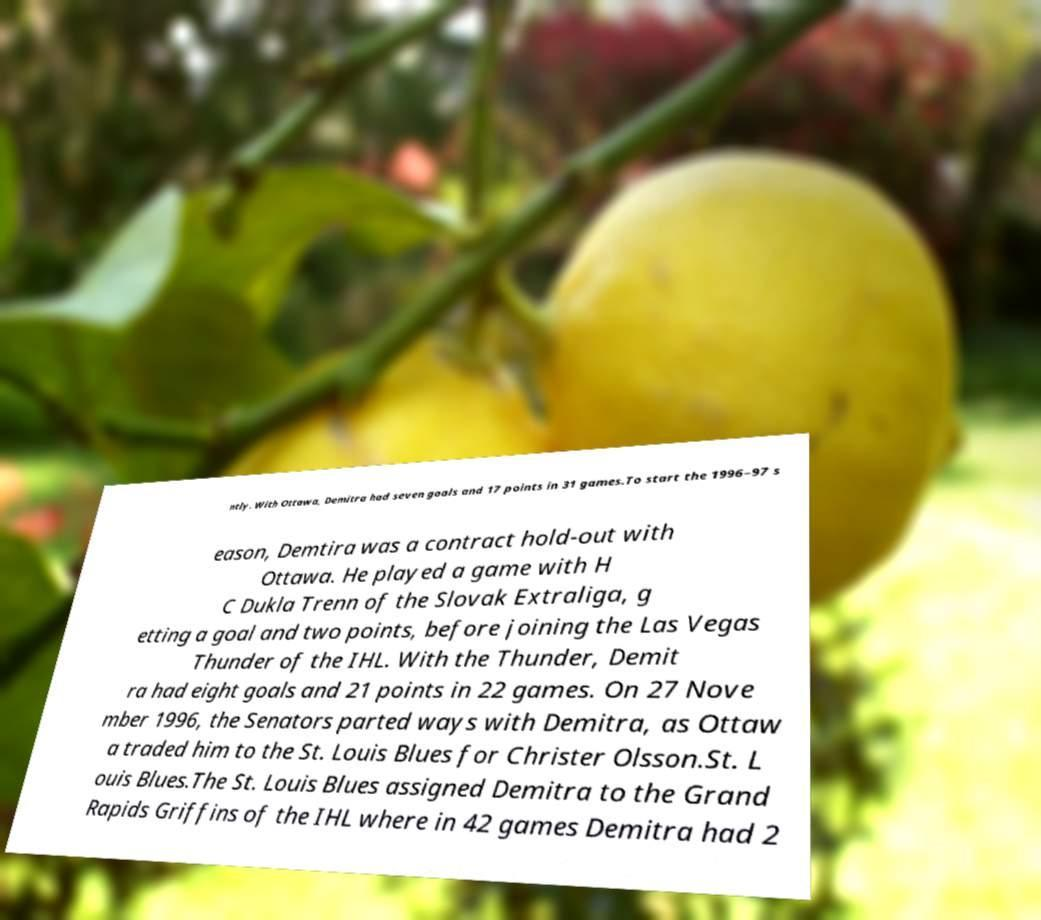Can you accurately transcribe the text from the provided image for me? ntly. With Ottawa, Demitra had seven goals and 17 points in 31 games.To start the 1996–97 s eason, Demtira was a contract hold-out with Ottawa. He played a game with H C Dukla Trenn of the Slovak Extraliga, g etting a goal and two points, before joining the Las Vegas Thunder of the IHL. With the Thunder, Demit ra had eight goals and 21 points in 22 games. On 27 Nove mber 1996, the Senators parted ways with Demitra, as Ottaw a traded him to the St. Louis Blues for Christer Olsson.St. L ouis Blues.The St. Louis Blues assigned Demitra to the Grand Rapids Griffins of the IHL where in 42 games Demitra had 2 